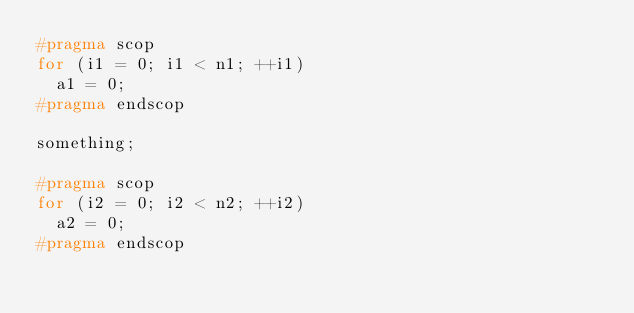<code> <loc_0><loc_0><loc_500><loc_500><_C_>#pragma scop
for (i1 = 0; i1 < n1; ++i1)
  a1 = 0;
#pragma endscop

something;

#pragma scop
for (i2 = 0; i2 < n2; ++i2)
  a2 = 0;
#pragma endscop

</code> 